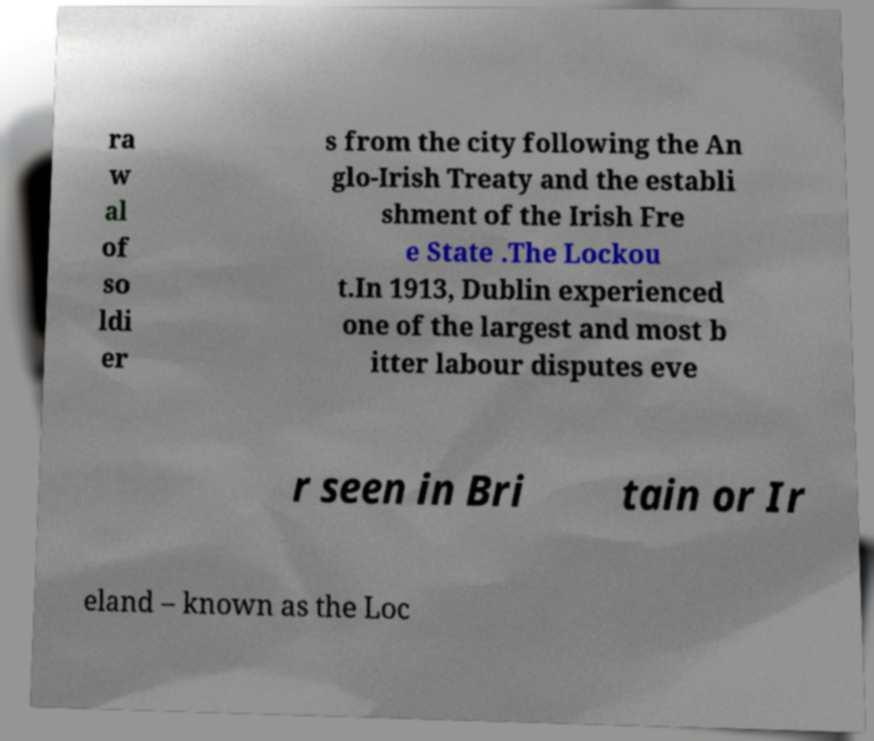For documentation purposes, I need the text within this image transcribed. Could you provide that? ra w al of so ldi er s from the city following the An glo-Irish Treaty and the establi shment of the Irish Fre e State .The Lockou t.In 1913, Dublin experienced one of the largest and most b itter labour disputes eve r seen in Bri tain or Ir eland – known as the Loc 